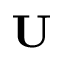<formula> <loc_0><loc_0><loc_500><loc_500>U</formula> 